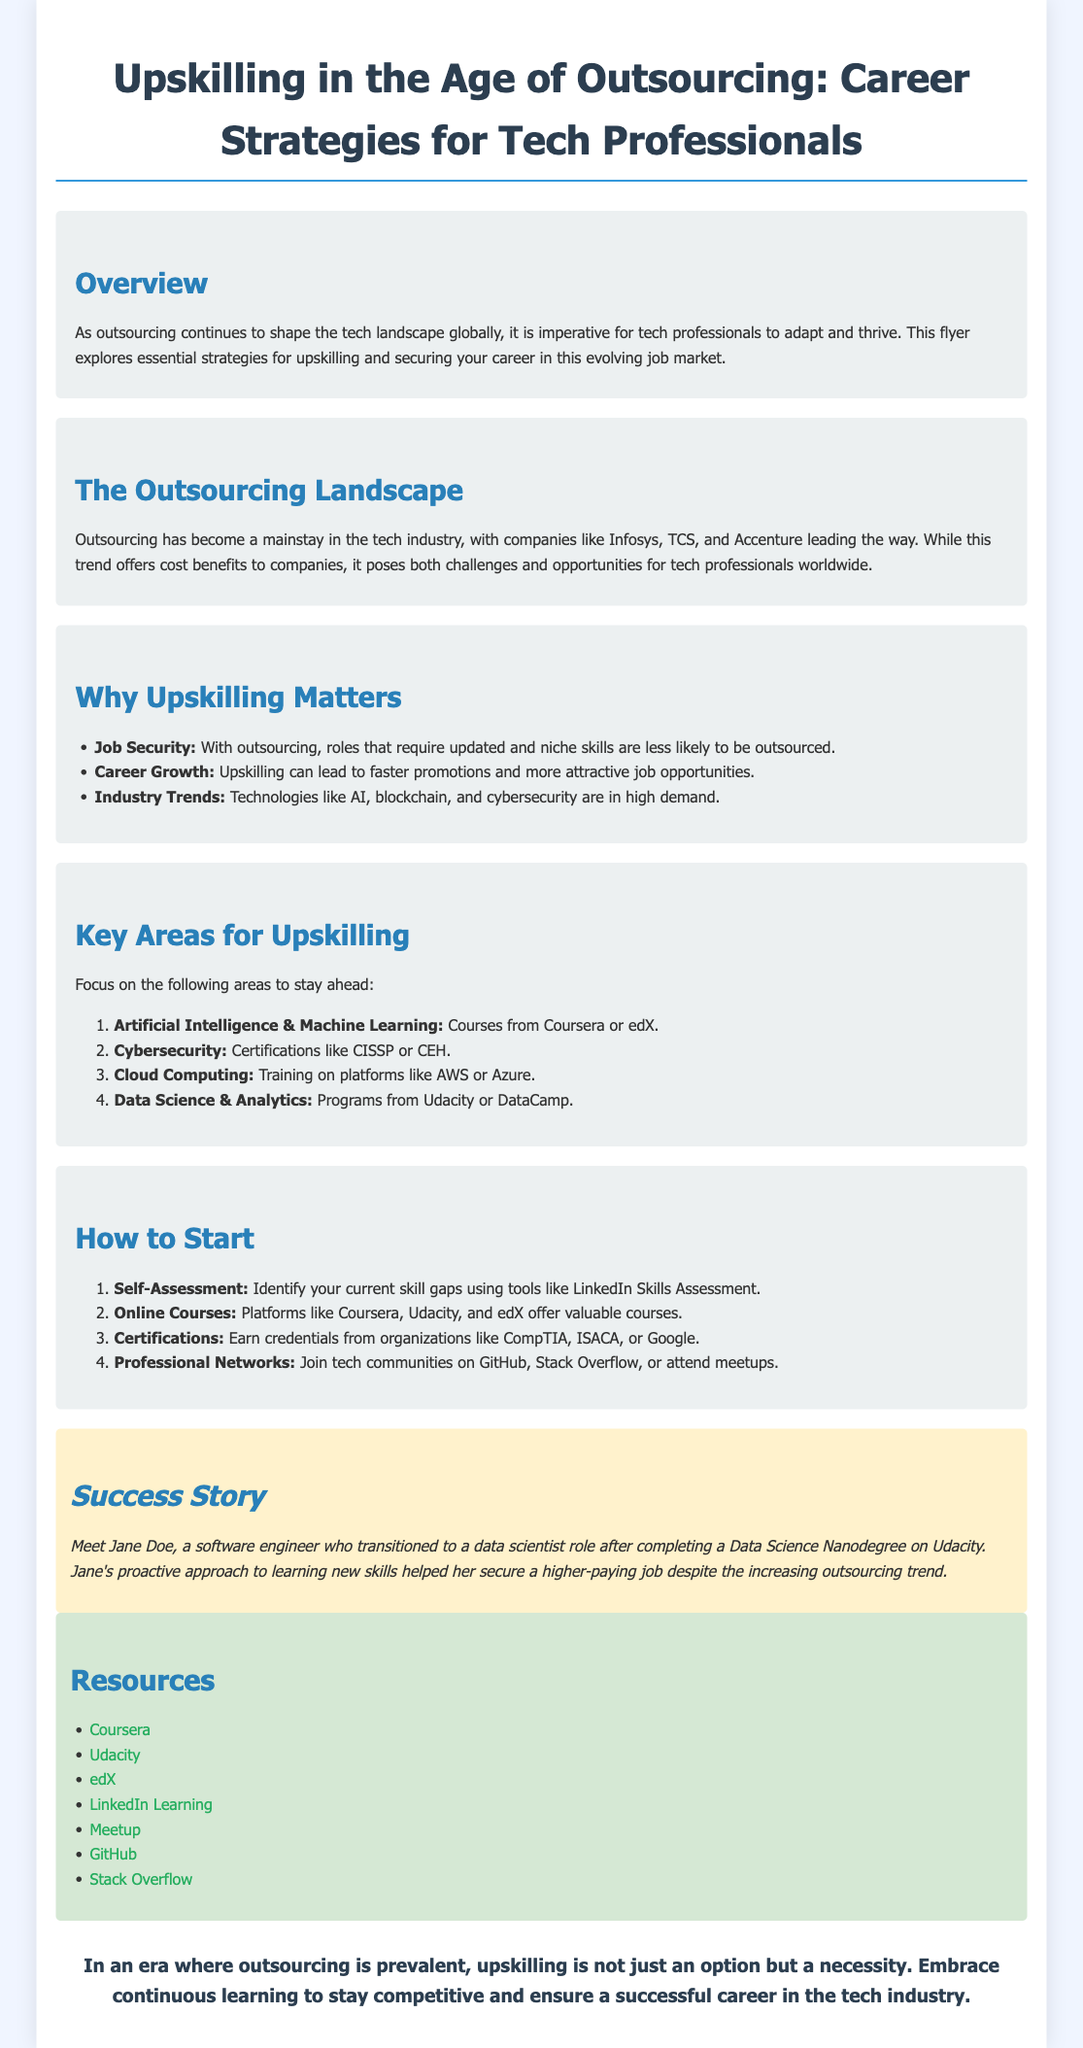What is the main focus of the flyer? The flyer explores essential strategies for upskilling and securing your career in this evolving job market due to outsourcing.
Answer: Upskilling strategies Which companies are mentioned as leaders in outsourcing? The document names Infosys, TCS, and Accenture as leading outsourcing companies in the tech industry.
Answer: Infosys, TCS, Accenture What is one reason why upskilling matters according to the flyer? The flyer states that roles requiring updated and niche skills are less likely to be outsourced, emphasizing job security as a reason for upskilling.
Answer: Job Security What area should tech professionals focus on for upskilling? The document lists Artificial Intelligence & Machine Learning among other areas as focus points for upskilling.
Answer: Artificial Intelligence & Machine Learning How can professionals start the process of upskilling? The flyer suggests self-assessment as the first step to identify current skill gaps.
Answer: Self-Assessment What success story is featured in the flyer? The success story highlights Jane Doe, a software engineer who became a data scientist after completing a Data Science Nanodegree.
Answer: Jane Doe What is the last message conveyed in the conclusion? The conclusion emphasizes that upskilling is a necessity for staying competitive in the tech industry amidst outsourcing trends.
Answer: Necessity of upskilling Which online platform is mentioned for obtaining valuable courses? The document recommends platforms like Coursera, Udacity, and edX for online courses as part of upskilling strategies.
Answer: Coursera, Udacity, edX 